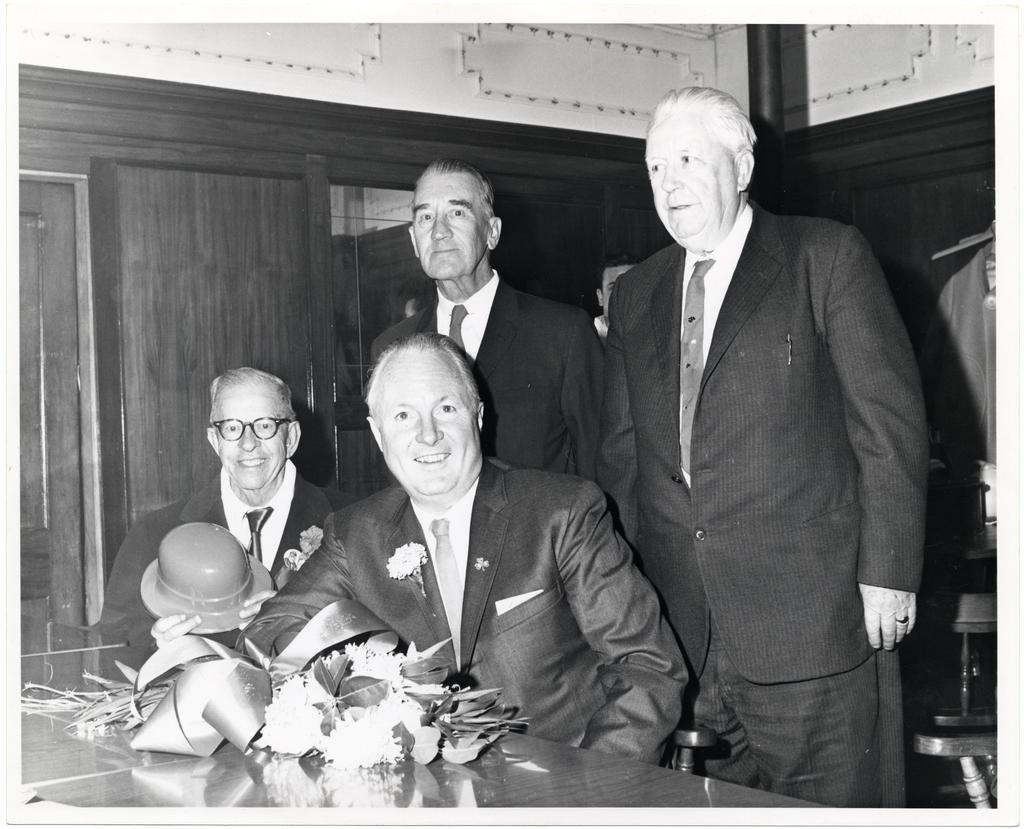How many people are present in the image? There are two people sitting in the image. What are the other individuals doing in the image? There are two men standing in the image. What are the men wearing? The men are wearing coats. What can be seen in the background of the image? There is a wall visible in the image. What type of hook can be seen hanging from the wall in the image? There is no hook visible in the image; only the wall is mentioned. Are the men wearing veils in the image? No, the men are not wearing veils; they are wearing coats. 